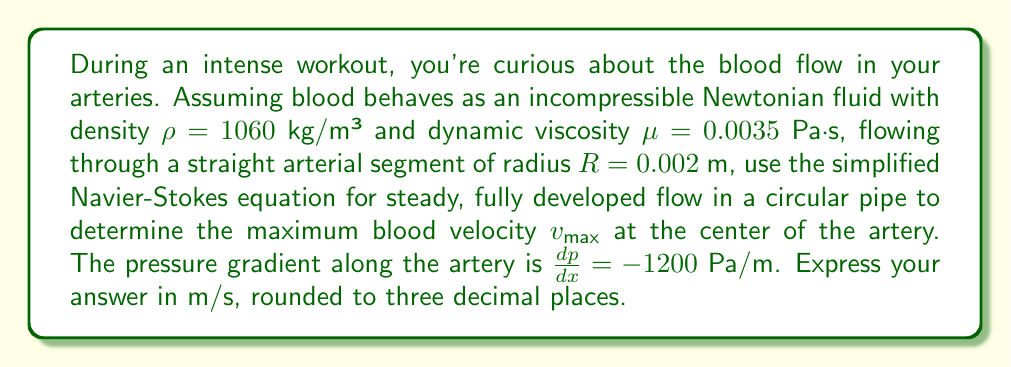What is the answer to this math problem? Let's approach this step-by-step using the simplified Navier-Stokes equation for steady, fully developed flow in a circular pipe:

1) The simplified Navier-Stokes equation for this scenario is:

   $$\frac{1}{r}\frac{d}{dr}\left(r\frac{dv}{dr}\right) = \frac{1}{\mu}\frac{dp}{dx}$$

2) Integrating this equation twice with respect to r, we get:

   $$v(r) = \frac{1}{4\mu}\frac{dp}{dx}(r^2 - R^2)$$

3) The maximum velocity occurs at the center of the pipe where r = 0:

   $$v_{max} = v(0) = -\frac{R^2}{4\mu}\frac{dp}{dx}$$

4) Now, let's substitute the given values:
   
   $R = 0.002$ m
   $\mu = 0.0035$ Pa·s
   $\frac{dp}{dx} = -1200$ Pa/m

5) Calculating:

   $$v_{max} = -\frac{(0.002)^2}{4(0.0035)}(-1200)$$

6) Simplifying:

   $$v_{max} = \frac{(4 \times 10^{-6})(1200)}{0.014} = 0.3428571429$$ m/s

7) Rounding to three decimal places:

   $$v_{max} \approx 0.343$$ m/s
Answer: 0.343 m/s 